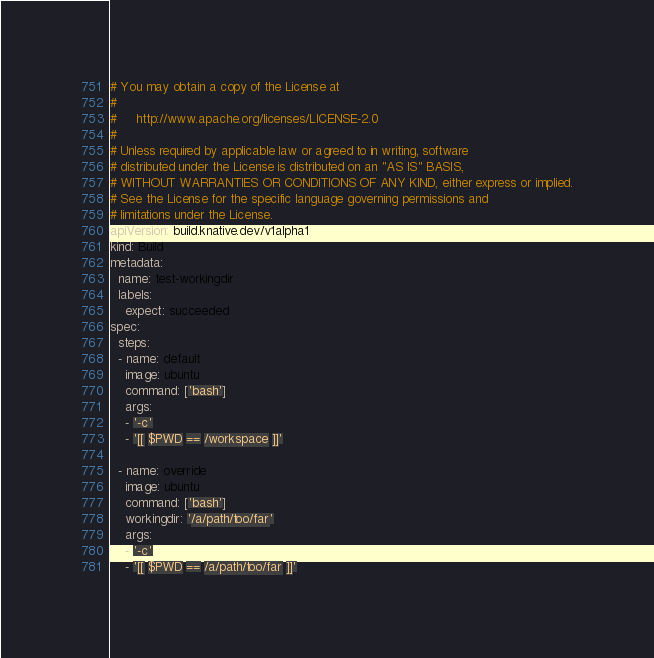<code> <loc_0><loc_0><loc_500><loc_500><_YAML_># You may obtain a copy of the License at
#
#     http://www.apache.org/licenses/LICENSE-2.0
#
# Unless required by applicable law or agreed to in writing, software
# distributed under the License is distributed on an "AS IS" BASIS,
# WITHOUT WARRANTIES OR CONDITIONS OF ANY KIND, either express or implied.
# See the License for the specific language governing permissions and
# limitations under the License.
apiVersion: build.knative.dev/v1alpha1
kind: Build
metadata:
  name: test-workingdir
  labels:
    expect: succeeded
spec:
  steps:
  - name: default
    image: ubuntu
    command: ['bash']
    args:
    - '-c'
    - '[[ $PWD == /workspace ]]'

  - name: override
    image: ubuntu
    command: ['bash']
    workingdir: '/a/path/too/far'
    args:
    - '-c'
    - '[[ $PWD == /a/path/too/far ]]'
</code> 